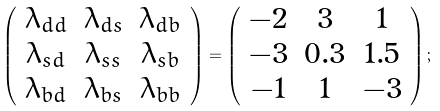Convert formula to latex. <formula><loc_0><loc_0><loc_500><loc_500>\left ( \begin{array} { c c c } { { \lambda _ { d d } } } & { { \lambda _ { d s } } } & { { \lambda _ { d b } } } \\ { { \lambda _ { s d } } } & { { \lambda _ { s s } } } & { { \lambda _ { s b } } } \\ { { \lambda _ { b d } } } & { { \lambda _ { b s } } } & { { \lambda _ { b b } } } \end{array} \right ) = \left ( \begin{array} { c c c } { - 2 } & { 3 } & { 1 } \\ { - 3 } & { 0 . 3 } & { 1 . 5 } \\ { - 1 } & { 1 } & { - 3 } \end{array} \right ) ;</formula> 